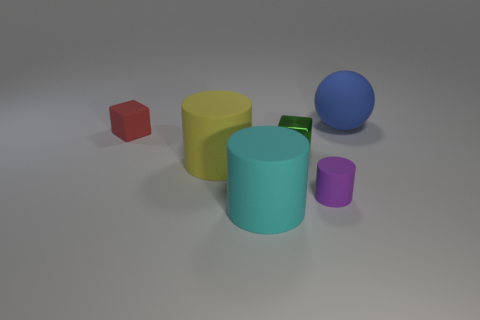How many things are in front of the small metallic cube and behind the large cyan rubber cylinder?
Ensure brevity in your answer.  2. How many big cyan matte objects are the same shape as the tiny purple object?
Offer a very short reply. 1. Are the blue thing and the small cylinder made of the same material?
Your response must be concise. Yes. There is a rubber object behind the small rubber object on the left side of the tiny green thing; what is its shape?
Your answer should be very brief. Sphere. What number of tiny metallic blocks are to the left of the matte cylinder that is to the right of the cyan object?
Give a very brief answer. 1. There is a big object that is both behind the purple rubber cylinder and left of the tiny cylinder; what is its material?
Offer a terse response. Rubber. The cyan thing that is the same size as the matte ball is what shape?
Give a very brief answer. Cylinder. What is the color of the small block right of the cylinder that is on the left side of the large thing that is in front of the tiny rubber cylinder?
Your response must be concise. Green. How many things are either big matte things on the left side of the large blue thing or tiny shiny blocks?
Make the answer very short. 3. What material is the other cube that is the same size as the red cube?
Your answer should be very brief. Metal. 